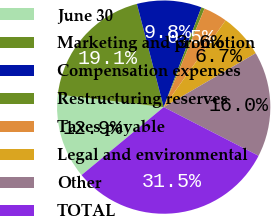<chart> <loc_0><loc_0><loc_500><loc_500><pie_chart><fcel>June 30<fcel>Marketing and promotion<fcel>Compensation expenses<fcel>Restructuring reserves<fcel>Taxes payable<fcel>Legal and environmental<fcel>Other<fcel>TOTAL<nl><fcel>12.89%<fcel>19.07%<fcel>9.79%<fcel>0.51%<fcel>3.61%<fcel>6.7%<fcel>15.98%<fcel>31.45%<nl></chart> 